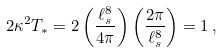Convert formula to latex. <formula><loc_0><loc_0><loc_500><loc_500>2 \kappa ^ { 2 } T _ { * } = 2 \left ( \frac { \ell _ { s } ^ { 8 } } { 4 \pi } \right ) \left ( \frac { 2 \pi } { \ell _ { s } ^ { 8 } } \right ) = 1 \, ,</formula> 